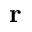<formula> <loc_0><loc_0><loc_500><loc_500>{ \mathbf r }</formula> 